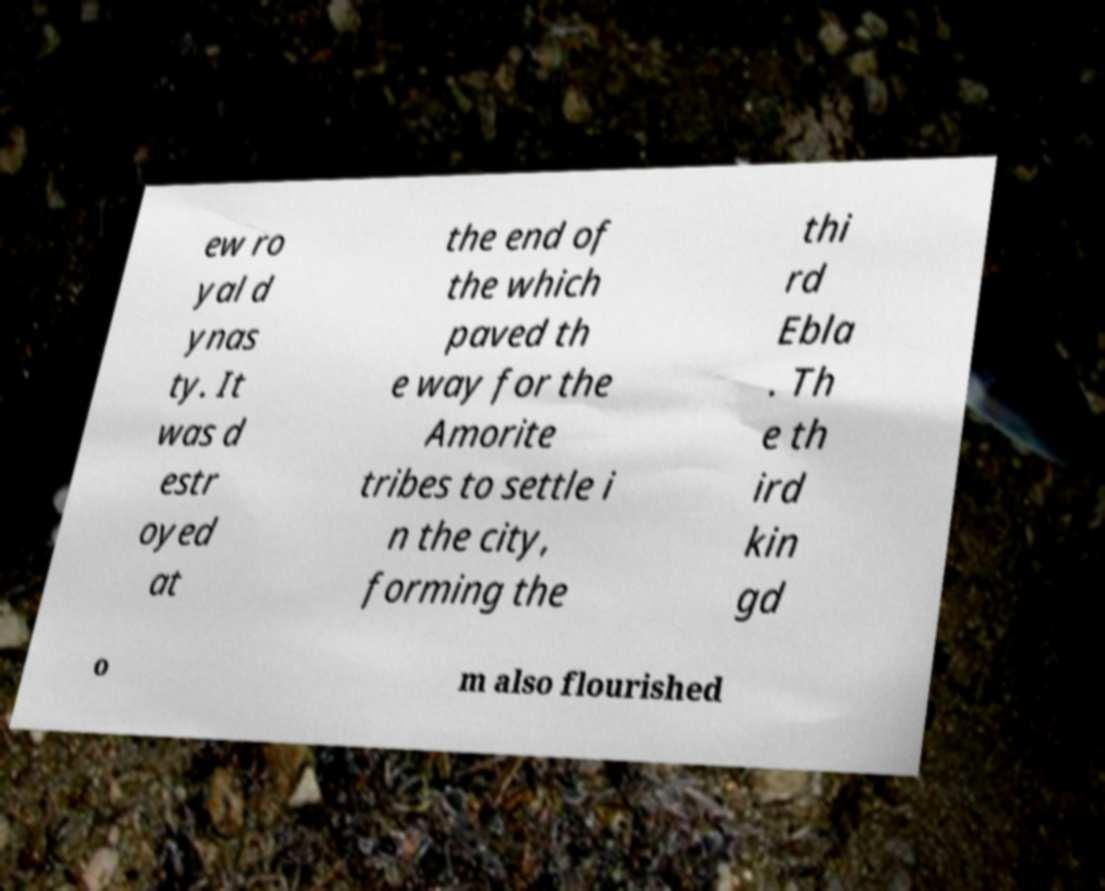Can you accurately transcribe the text from the provided image for me? ew ro yal d ynas ty. It was d estr oyed at the end of the which paved th e way for the Amorite tribes to settle i n the city, forming the thi rd Ebla . Th e th ird kin gd o m also flourished 